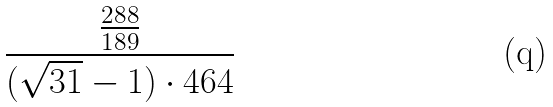<formula> <loc_0><loc_0><loc_500><loc_500>\frac { \frac { 2 8 8 } { 1 8 9 } } { ( \sqrt { 3 1 } - 1 ) \cdot 4 6 4 }</formula> 